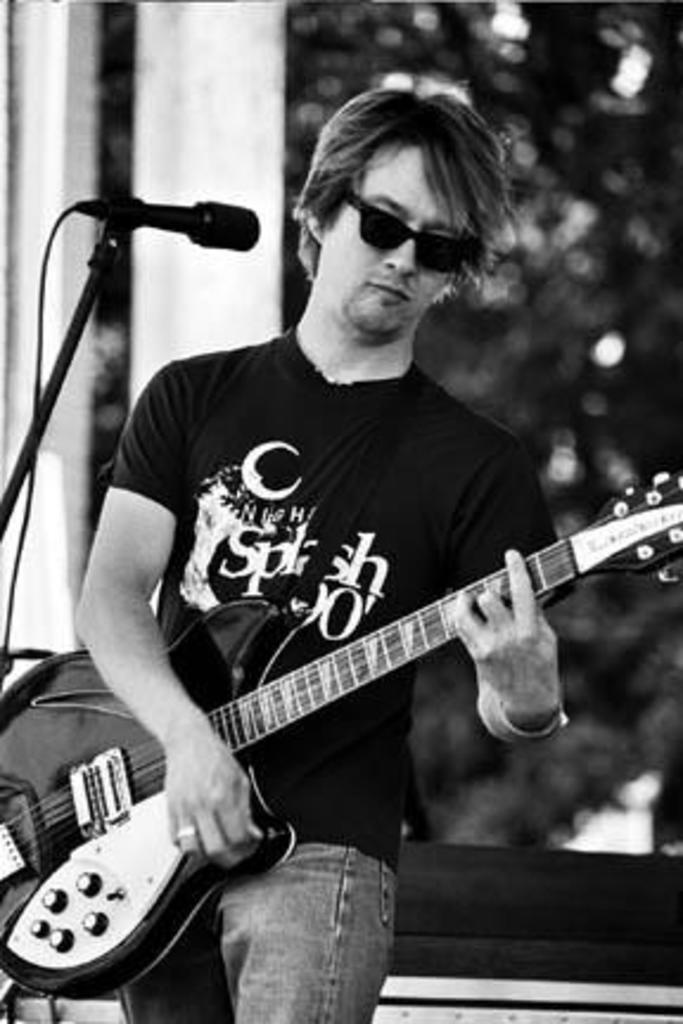Could you give a brief overview of what you see in this image? In this image there is a musician standing and holding a guitar in his hand. In front of him there is a mic and a black colour stand with the wires attached to it. In the background there are trees and wall. 